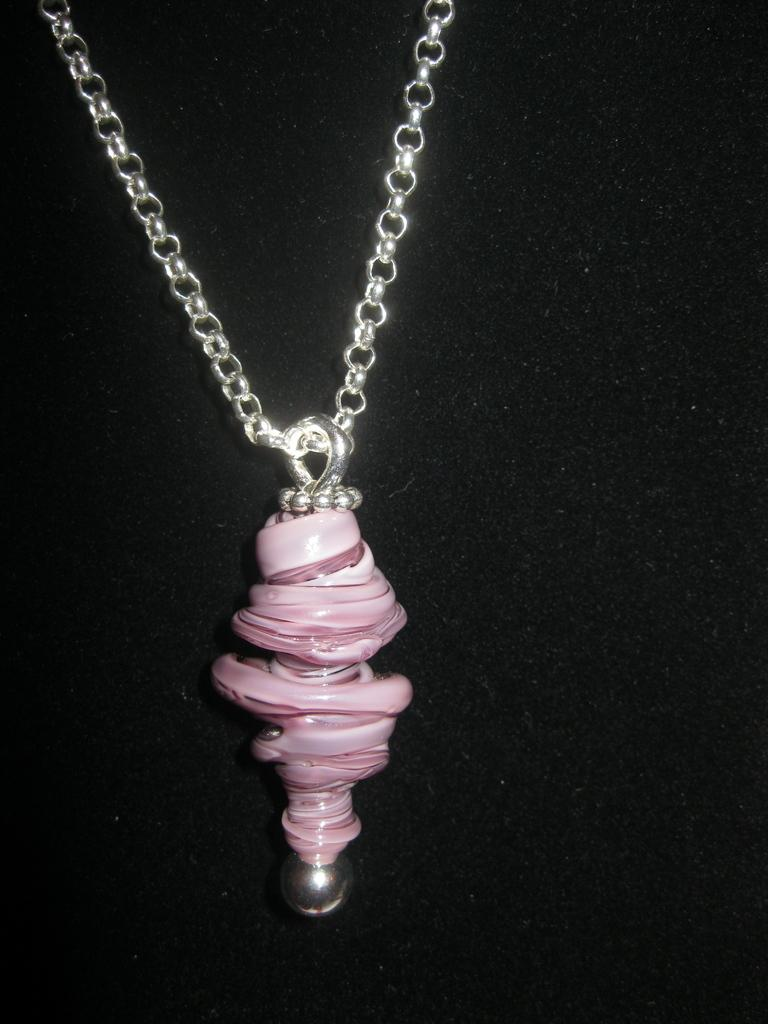What type of jewelry is visible in the image? There is a chain necklace in the image. What is attached to the chain necklace? There is a pendant on the necklace in the image. How many clovers can be seen growing on the pendant in the image? There are no clovers present on the pendant in the image. What type of liquid is dripping from the pendant in the image? There is no liquid present on the pendant in the image. 